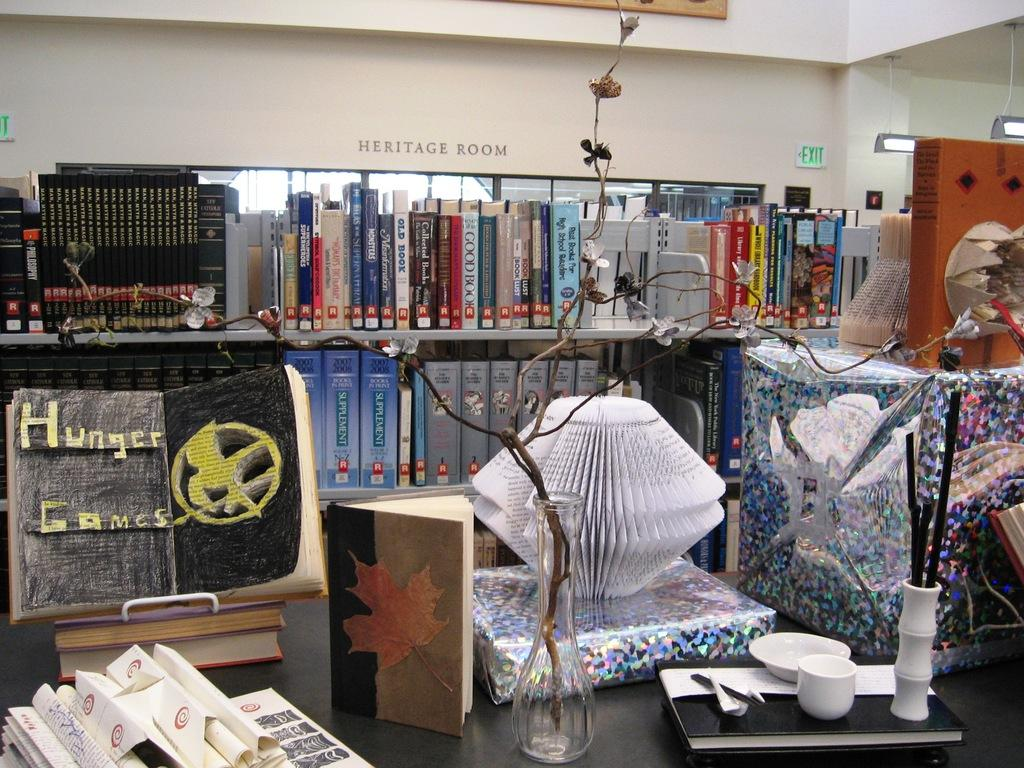<image>
Write a terse but informative summary of the picture. Submissions to the Heritage Room of the Athens Regional Library are being depicted. 